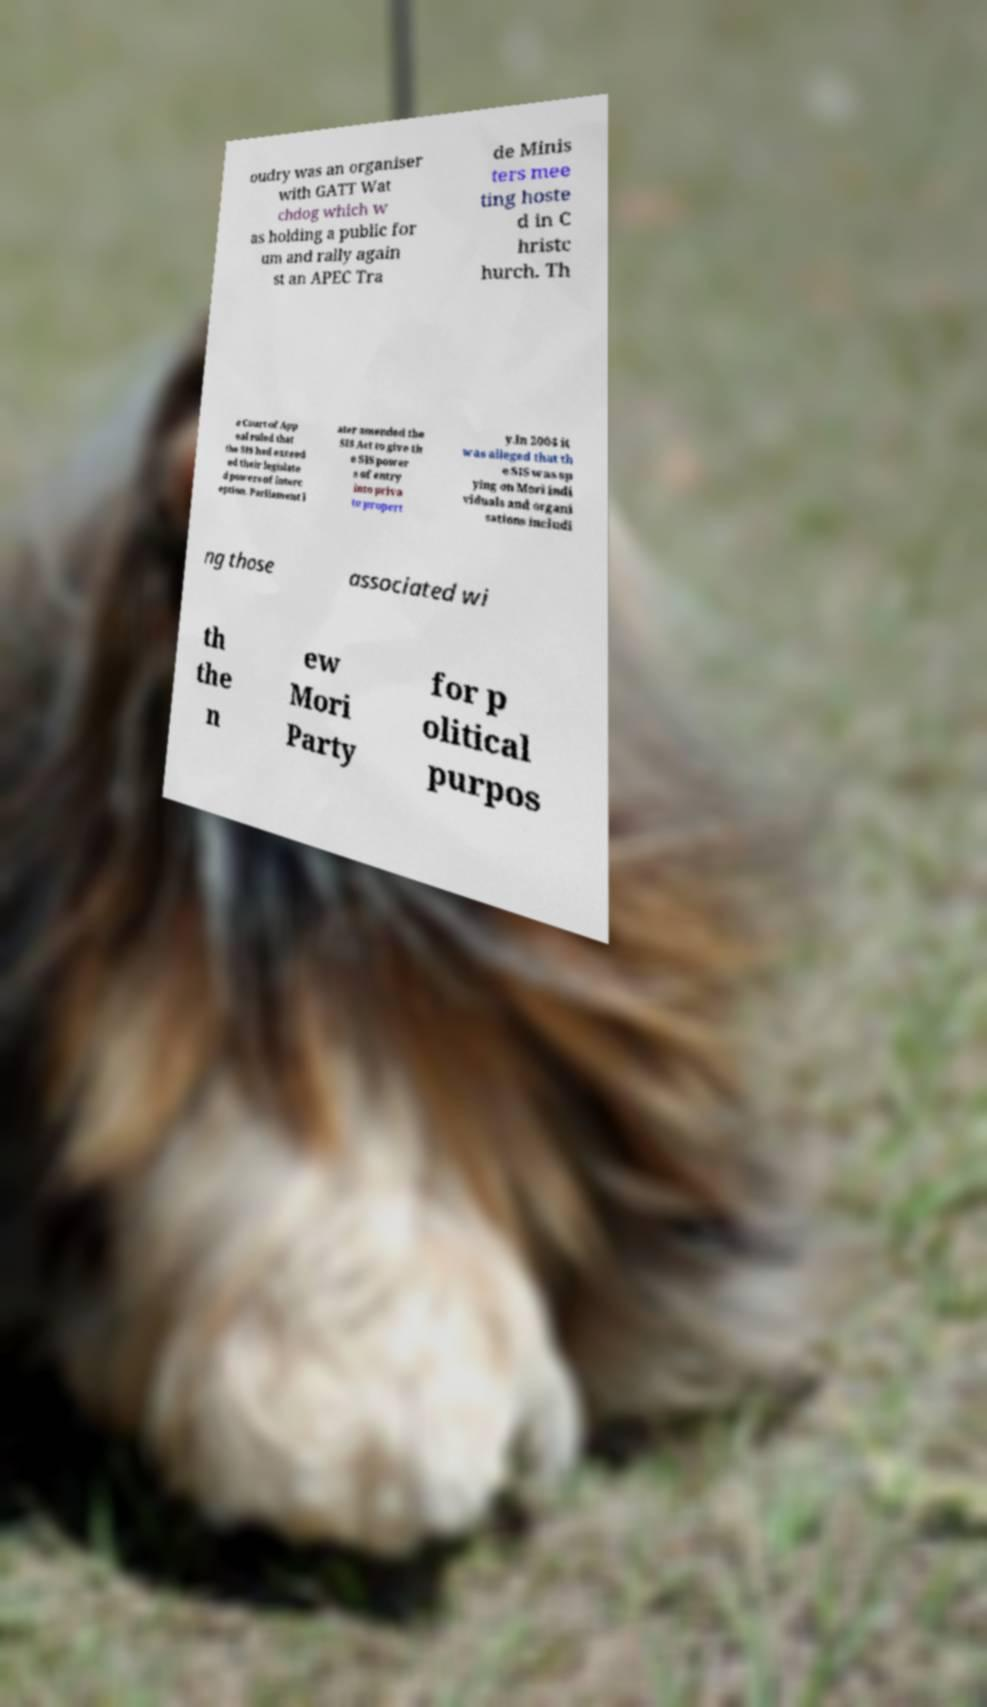Could you assist in decoding the text presented in this image and type it out clearly? oudry was an organiser with GATT Wat chdog which w as holding a public for um and rally again st an APEC Tra de Minis ters mee ting hoste d in C hristc hurch. Th e Court of App eal ruled that the SIS had exceed ed their legislate d powers of interc eption. Parliament l ater amended the SIS Act to give th e SIS power s of entry into priva te propert y.In 2004 it was alleged that th e SIS was sp ying on Mori indi viduals and organi sations includi ng those associated wi th the n ew Mori Party for p olitical purpos 